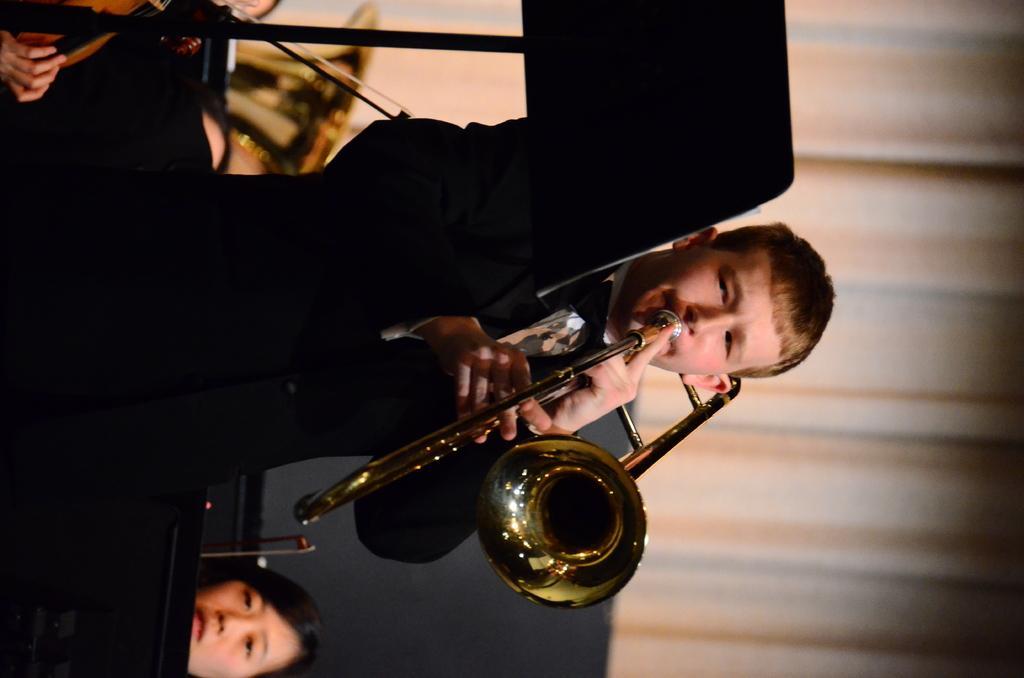In one or two sentences, can you explain what this image depicts? In this image, we can see a man playing tuba and in the background, there are some other people and we can see a curtain. 